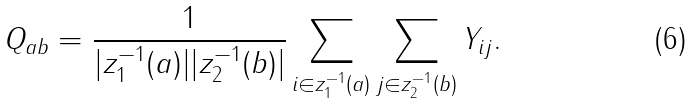<formula> <loc_0><loc_0><loc_500><loc_500>Q _ { a b } = \frac { 1 } { | z _ { 1 } ^ { - 1 } ( a ) | | z _ { 2 } ^ { - 1 } ( b ) | } \sum _ { i \in z _ { 1 } ^ { - 1 } ( a ) } \sum _ { j \in z _ { 2 } ^ { - 1 } ( b ) } Y _ { i j } .</formula> 